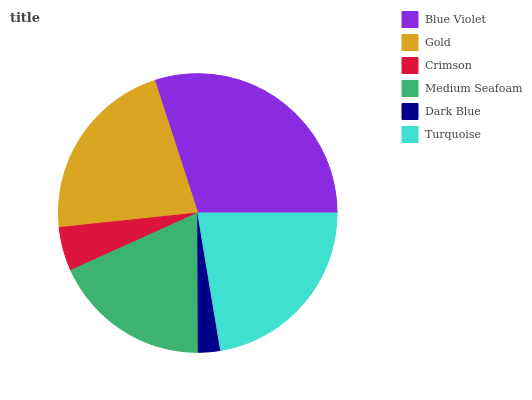Is Dark Blue the minimum?
Answer yes or no. Yes. Is Blue Violet the maximum?
Answer yes or no. Yes. Is Gold the minimum?
Answer yes or no. No. Is Gold the maximum?
Answer yes or no. No. Is Blue Violet greater than Gold?
Answer yes or no. Yes. Is Gold less than Blue Violet?
Answer yes or no. Yes. Is Gold greater than Blue Violet?
Answer yes or no. No. Is Blue Violet less than Gold?
Answer yes or no. No. Is Gold the high median?
Answer yes or no. Yes. Is Medium Seafoam the low median?
Answer yes or no. Yes. Is Crimson the high median?
Answer yes or no. No. Is Gold the low median?
Answer yes or no. No. 